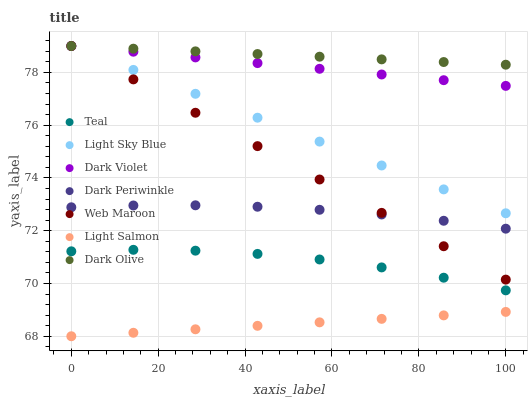Does Light Salmon have the minimum area under the curve?
Answer yes or no. Yes. Does Dark Olive have the maximum area under the curve?
Answer yes or no. Yes. Does Web Maroon have the minimum area under the curve?
Answer yes or no. No. Does Web Maroon have the maximum area under the curve?
Answer yes or no. No. Is Light Sky Blue the smoothest?
Answer yes or no. Yes. Is Teal the roughest?
Answer yes or no. Yes. Is Dark Olive the smoothest?
Answer yes or no. No. Is Dark Olive the roughest?
Answer yes or no. No. Does Light Salmon have the lowest value?
Answer yes or no. Yes. Does Web Maroon have the lowest value?
Answer yes or no. No. Does Light Sky Blue have the highest value?
Answer yes or no. Yes. Does Teal have the highest value?
Answer yes or no. No. Is Light Salmon less than Dark Violet?
Answer yes or no. Yes. Is Web Maroon greater than Light Salmon?
Answer yes or no. Yes. Does Light Sky Blue intersect Dark Olive?
Answer yes or no. Yes. Is Light Sky Blue less than Dark Olive?
Answer yes or no. No. Is Light Sky Blue greater than Dark Olive?
Answer yes or no. No. Does Light Salmon intersect Dark Violet?
Answer yes or no. No. 